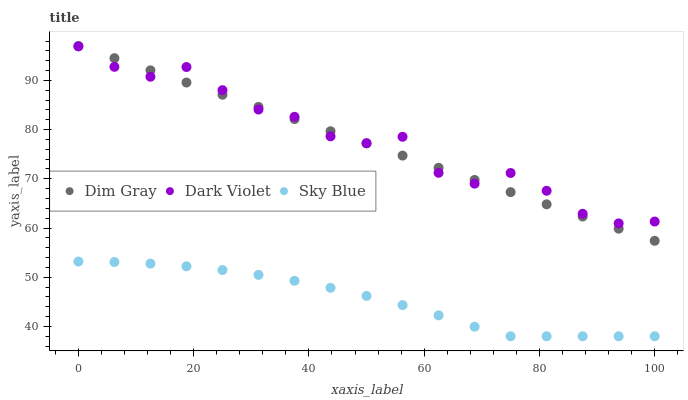Does Sky Blue have the minimum area under the curve?
Answer yes or no. Yes. Does Dark Violet have the maximum area under the curve?
Answer yes or no. Yes. Does Dim Gray have the minimum area under the curve?
Answer yes or no. No. Does Dim Gray have the maximum area under the curve?
Answer yes or no. No. Is Dim Gray the smoothest?
Answer yes or no. Yes. Is Dark Violet the roughest?
Answer yes or no. Yes. Is Dark Violet the smoothest?
Answer yes or no. No. Is Dim Gray the roughest?
Answer yes or no. No. Does Sky Blue have the lowest value?
Answer yes or no. Yes. Does Dim Gray have the lowest value?
Answer yes or no. No. Does Dim Gray have the highest value?
Answer yes or no. Yes. Does Dark Violet have the highest value?
Answer yes or no. No. Is Sky Blue less than Dark Violet?
Answer yes or no. Yes. Is Dim Gray greater than Sky Blue?
Answer yes or no. Yes. Does Dim Gray intersect Dark Violet?
Answer yes or no. Yes. Is Dim Gray less than Dark Violet?
Answer yes or no. No. Is Dim Gray greater than Dark Violet?
Answer yes or no. No. Does Sky Blue intersect Dark Violet?
Answer yes or no. No. 